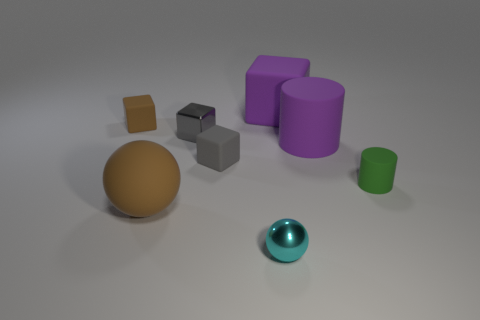Add 1 big purple things. How many objects exist? 9 Subtract 0 cyan cylinders. How many objects are left? 8 Subtract all cylinders. How many objects are left? 6 Subtract 1 cubes. How many cubes are left? 3 Subtract all yellow blocks. Subtract all green cylinders. How many blocks are left? 4 Subtract all red cylinders. How many purple spheres are left? 0 Subtract all large purple cylinders. Subtract all green rubber cylinders. How many objects are left? 6 Add 8 small cyan metallic objects. How many small cyan metallic objects are left? 9 Add 7 brown blocks. How many brown blocks exist? 8 Subtract all brown balls. How many balls are left? 1 